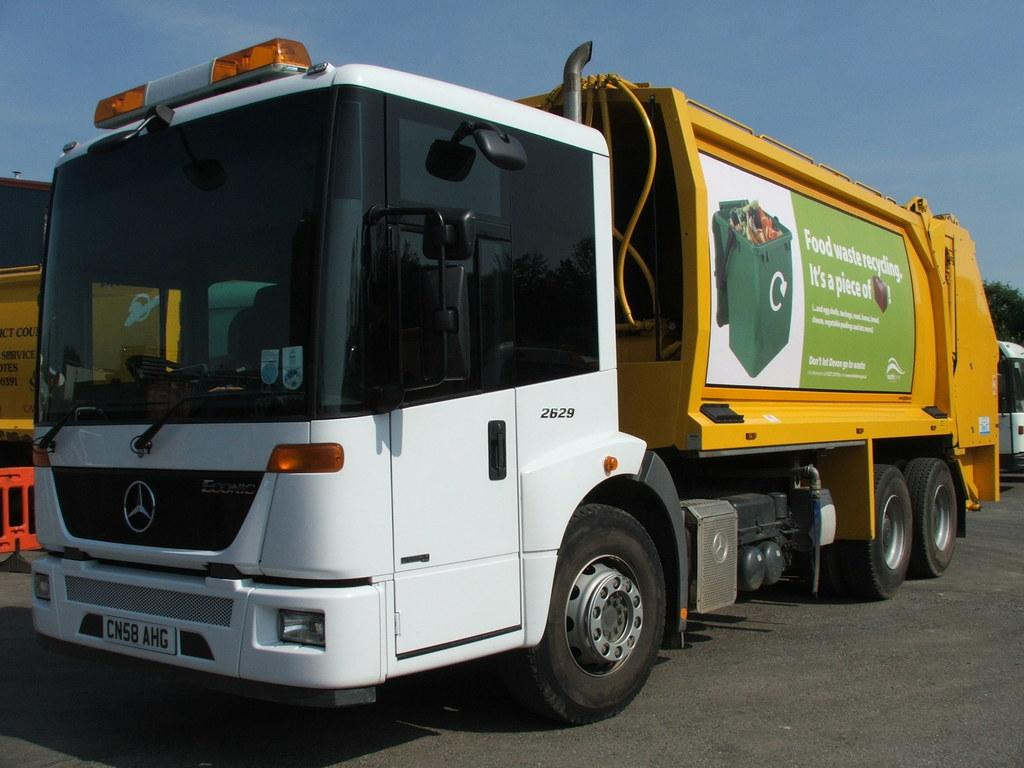<image>
Render a clear and concise summary of the photo. A truck has an advertisement for food waste recycling on it. 